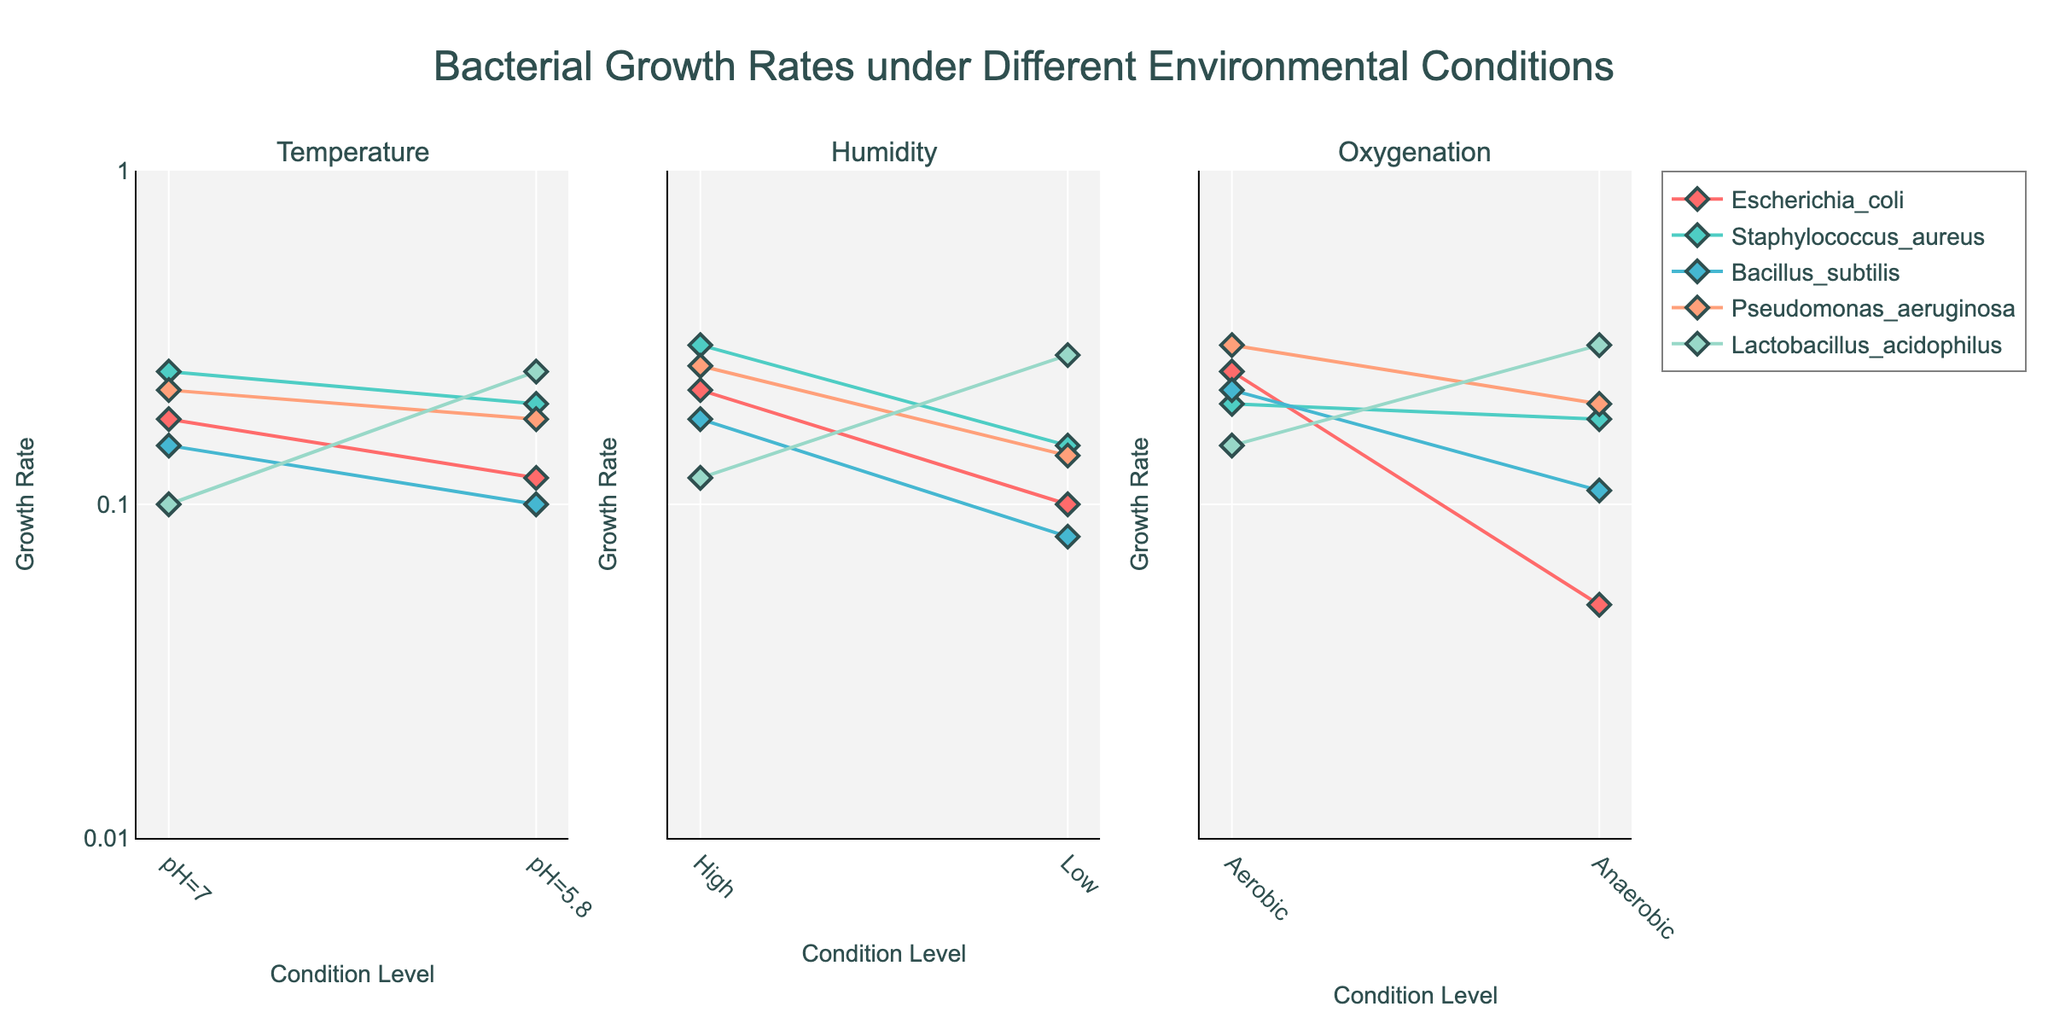What's the title of the plot? The title of the plot is displayed at the top, centered above the subplots.
Answer: Bacterial Growth Rates under Different Environmental Conditions Which bacterial culture shows the highest growth rate in aerobic conditions? To find the highest growth rate in aerobic conditions, look at the Oxygenation subplot. Among the bacterial cultures displayed, identify the one with the highest value on the Aerobic condition axis.
Answer: Pseudomonas aeruginosa What is the range of the y-axis, and how is it scaled? The y-axis range is from 0.01 to 1, and it is scaled logarithmically (as indicated by the type="log" in the code). The tick values are shown as 0.01, 0.1, and 1.
Answer: 0.01 to 1, logarithmic scale Which bacterial culture has a higher growth rate at a pH of 7, Escherichia coli or Bacillus subtilis? Look at the data points for Escherichia coli and Bacillus subtilis along the Temperature factor under pH 7. Compare their growth rates.
Answer: Escherichia coli What trend can you observe for Lactobacillus acidophilus under different humidity conditions? Observe the Humidity subplot for Lactobacillus acidophilus. Note the growth rate values for both High and Low humidity conditions and determine the trend.
Answer: Higher growth rate in Low humidity In which condition does Staphylococcus aureus exhibit the lowest growth rate? Locate the data points for Staphylococcus aureus across all subplots. Identify the lowest growth rate value and the corresponding condition.
Answer: Low Humidity How does the growth rate of Pseudomonas aeruginosa change with temperature at different pH levels? Examine the Temperature subplot for Pseudomonas aeruginosa. Observe the values at pH 7 and pH 5.8 and note the change in growth rate between these levels.
Answer: Decreases from 0.22 at pH 7 to 0.18 at pH 5.8 Which bacterial culture shows the most significant difference in growth rates under aerobic versus anaerobic conditions? Compare the growth rates of each bacterial culture between the Aerobic and Anaerobic conditions in the Oxygenation subplot and find the one with the largest difference.
Answer: Escherichia coli 